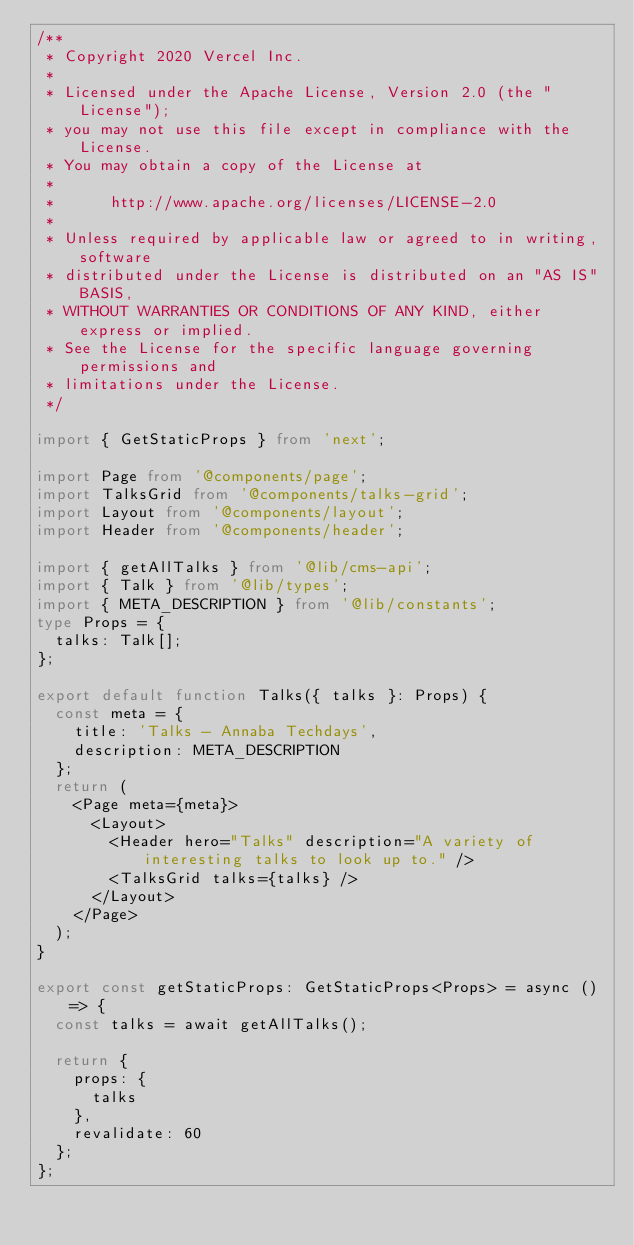<code> <loc_0><loc_0><loc_500><loc_500><_TypeScript_>/**
 * Copyright 2020 Vercel Inc.
 *
 * Licensed under the Apache License, Version 2.0 (the "License");
 * you may not use this file except in compliance with the License.
 * You may obtain a copy of the License at
 *
 *      http://www.apache.org/licenses/LICENSE-2.0
 *
 * Unless required by applicable law or agreed to in writing, software
 * distributed under the License is distributed on an "AS IS" BASIS,
 * WITHOUT WARRANTIES OR CONDITIONS OF ANY KIND, either express or implied.
 * See the License for the specific language governing permissions and
 * limitations under the License.
 */

import { GetStaticProps } from 'next';

import Page from '@components/page';
import TalksGrid from '@components/talks-grid';
import Layout from '@components/layout';
import Header from '@components/header';

import { getAllTalks } from '@lib/cms-api';
import { Talk } from '@lib/types';
import { META_DESCRIPTION } from '@lib/constants';
type Props = {
  talks: Talk[];
};

export default function Talks({ talks }: Props) {
  const meta = {
    title: 'Talks - Annaba Techdays',
    description: META_DESCRIPTION
  };
  return (
    <Page meta={meta}>
      <Layout>
        <Header hero="Talks" description="A variety of interesting talks to look up to." />
        <TalksGrid talks={talks} />
      </Layout>
    </Page>
  );
}

export const getStaticProps: GetStaticProps<Props> = async () => {
  const talks = await getAllTalks();

  return {
    props: {
      talks
    },
    revalidate: 60
  };
};
</code> 